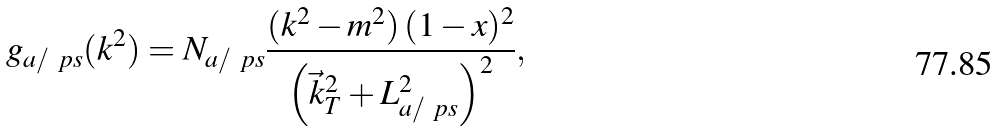Convert formula to latex. <formula><loc_0><loc_0><loc_500><loc_500>g _ { a / \ p s } ( k ^ { 2 } ) = N _ { a / \ p s } \frac { ( k ^ { 2 } - m ^ { 2 } ) \, ( 1 - x ) ^ { 2 } } { \left ( \vec { k } _ { T } ^ { 2 } + L _ { a / \ p s } ^ { 2 } \right ) ^ { 2 } } ,</formula> 